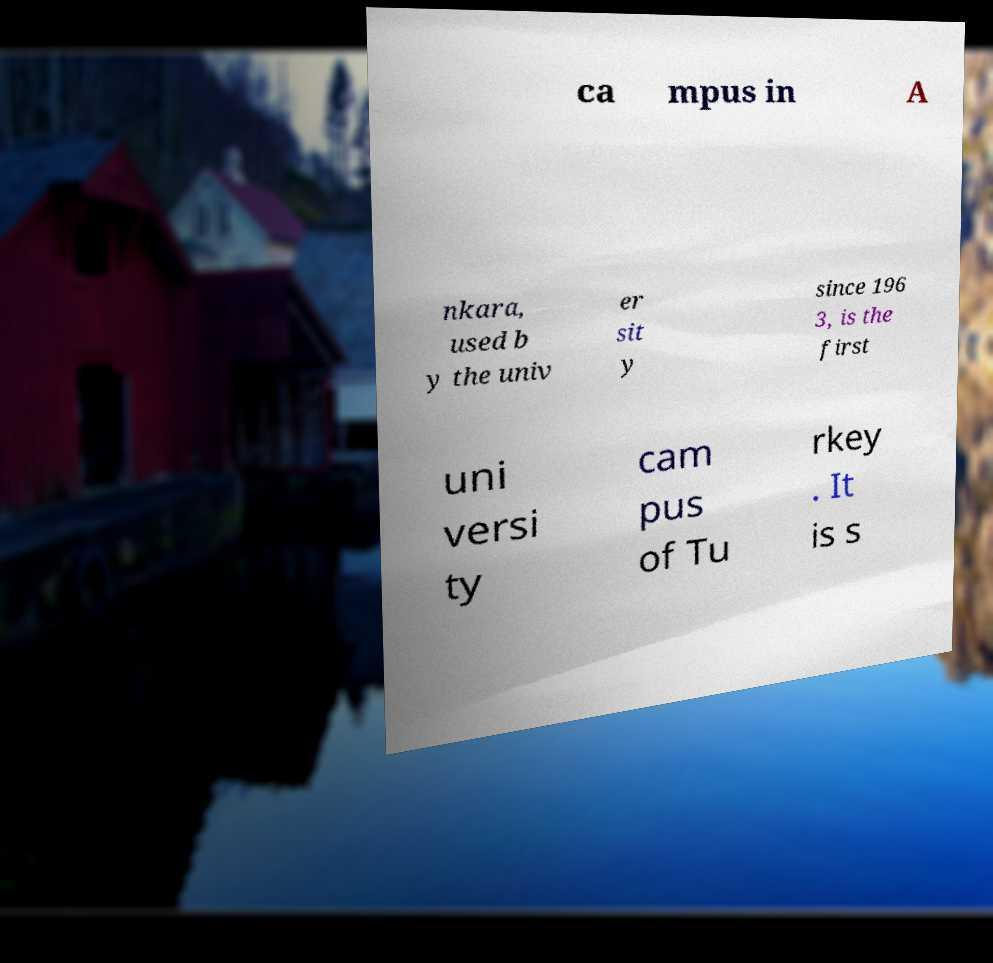For documentation purposes, I need the text within this image transcribed. Could you provide that? ca mpus in A nkara, used b y the univ er sit y since 196 3, is the first uni versi ty cam pus of Tu rkey . It is s 